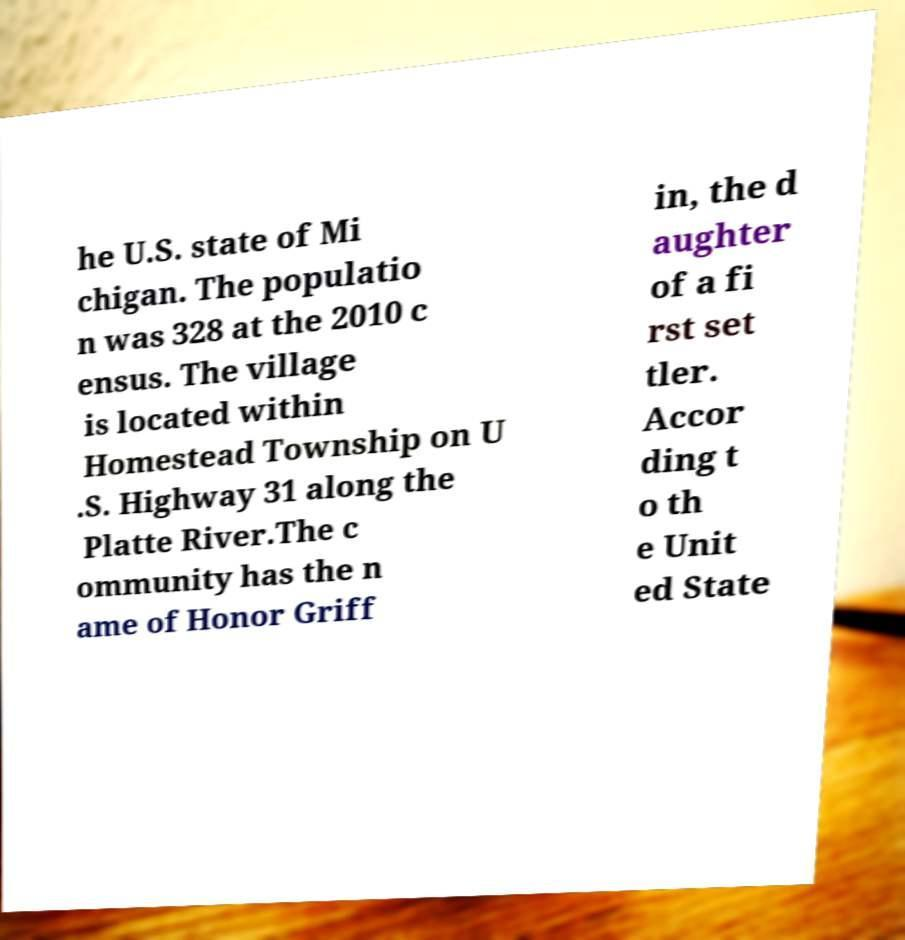What messages or text are displayed in this image? I need them in a readable, typed format. he U.S. state of Mi chigan. The populatio n was 328 at the 2010 c ensus. The village is located within Homestead Township on U .S. Highway 31 along the Platte River.The c ommunity has the n ame of Honor Griff in, the d aughter of a fi rst set tler. Accor ding t o th e Unit ed State 